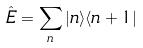<formula> <loc_0><loc_0><loc_500><loc_500>\hat { E } = \sum _ { n } | n \rangle \langle n + 1 |</formula> 